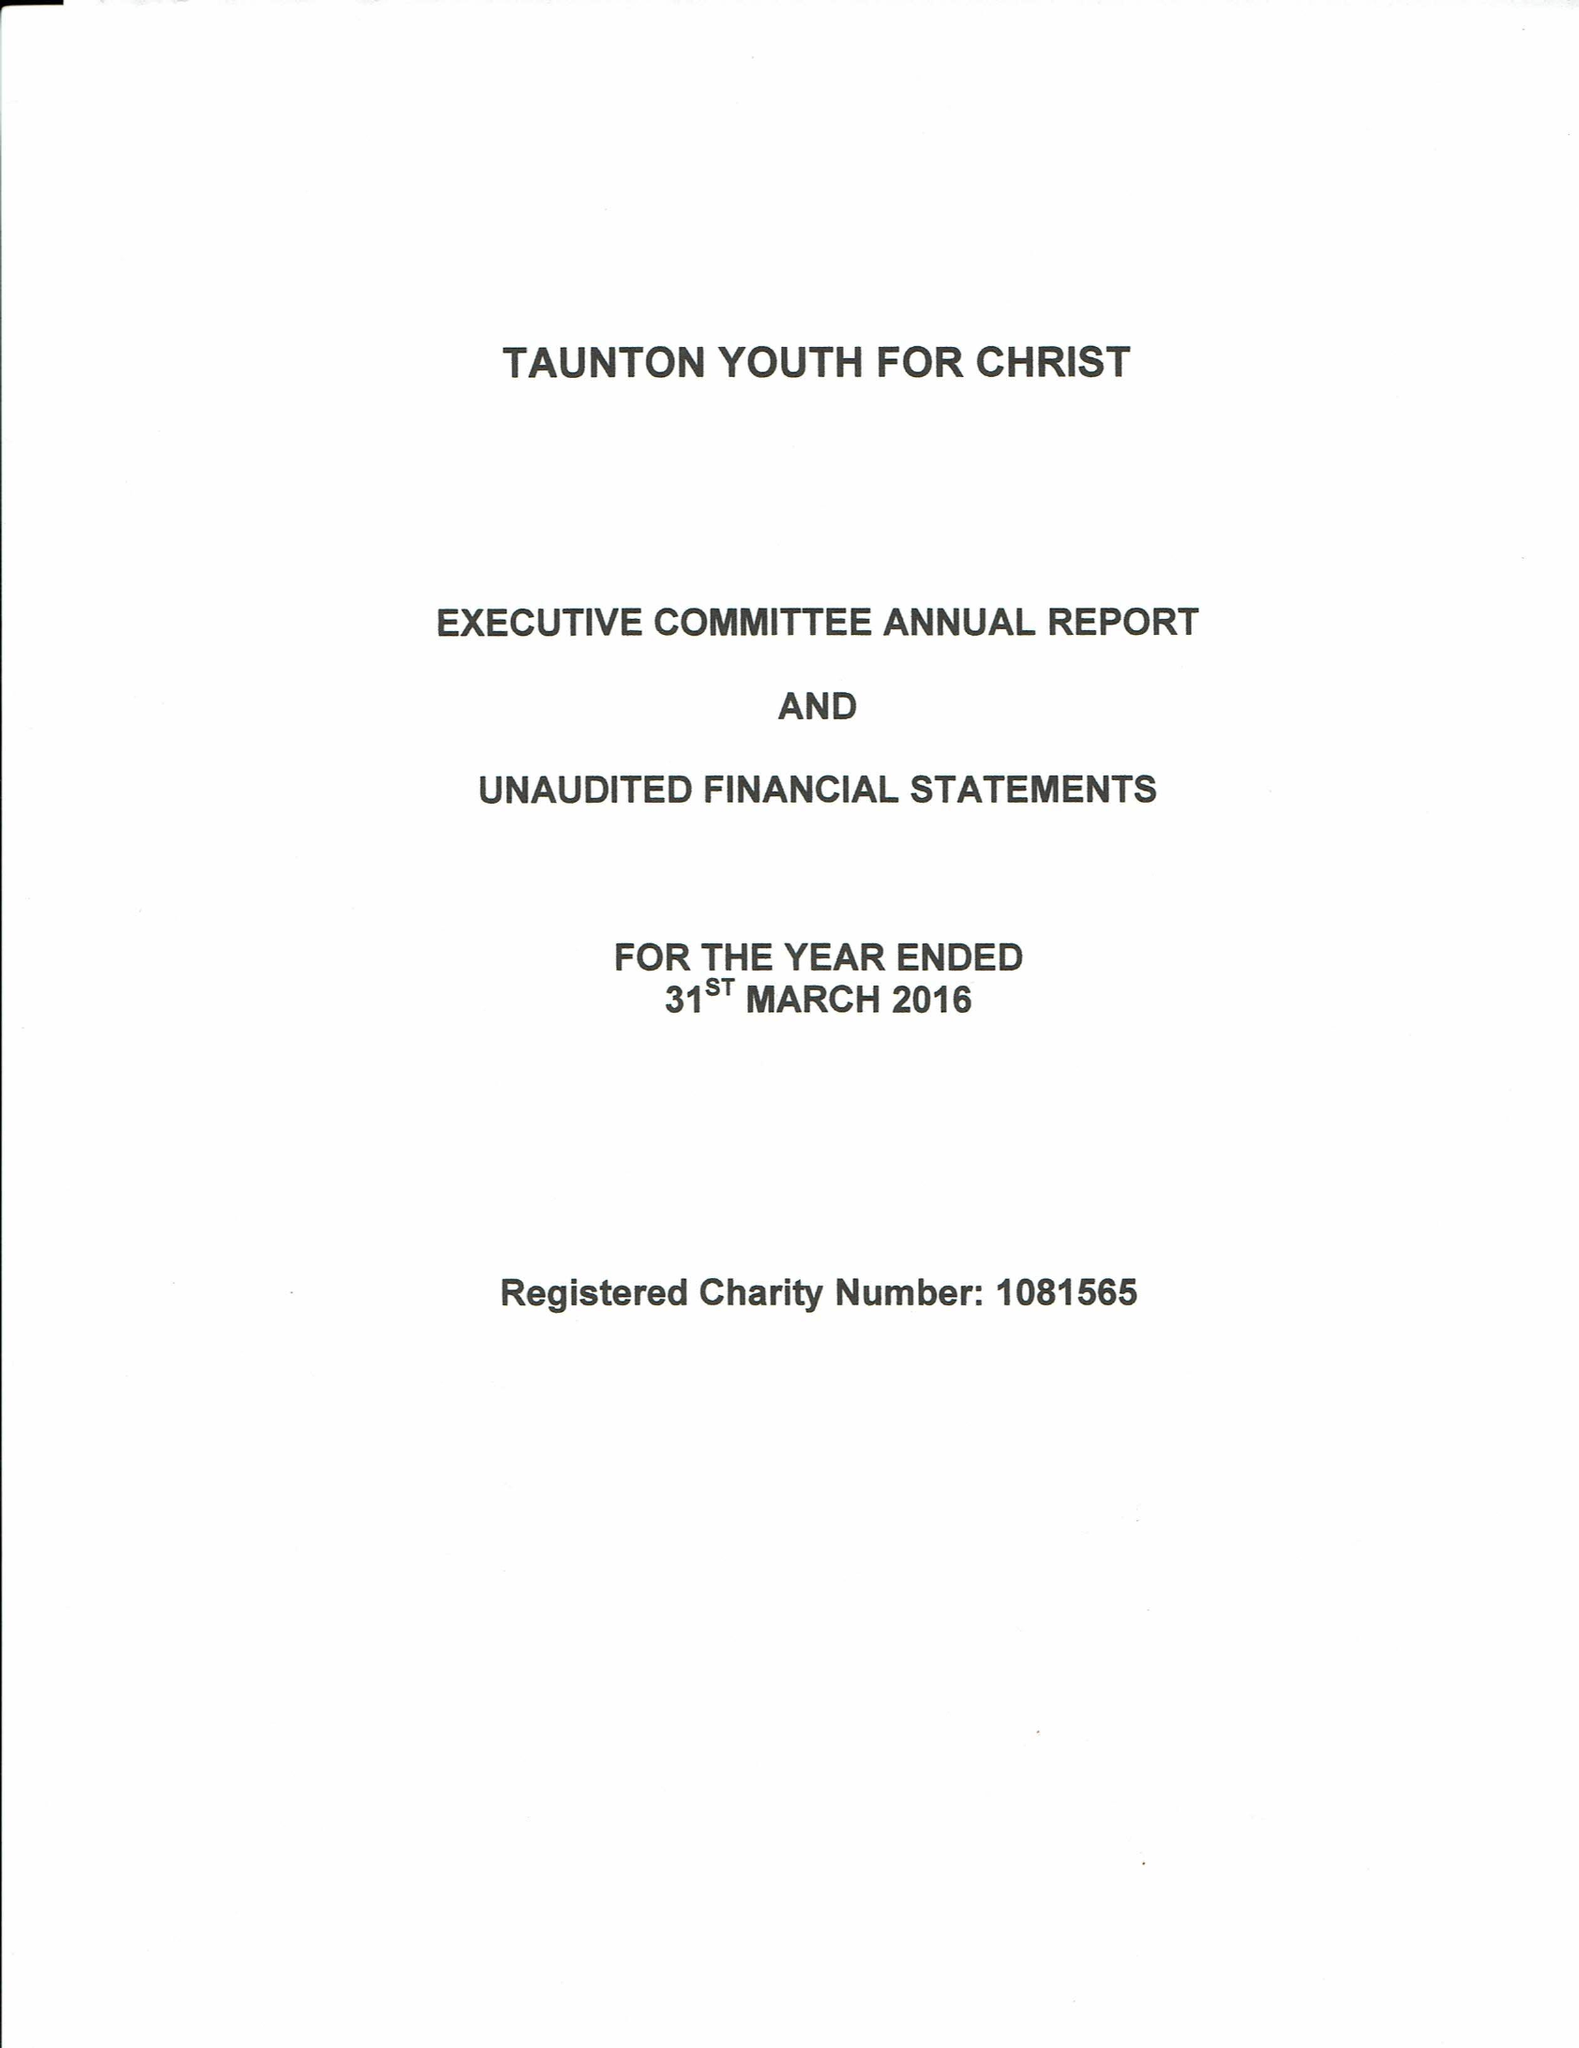What is the value for the charity_name?
Answer the question using a single word or phrase. Taunton Youth For Christ 